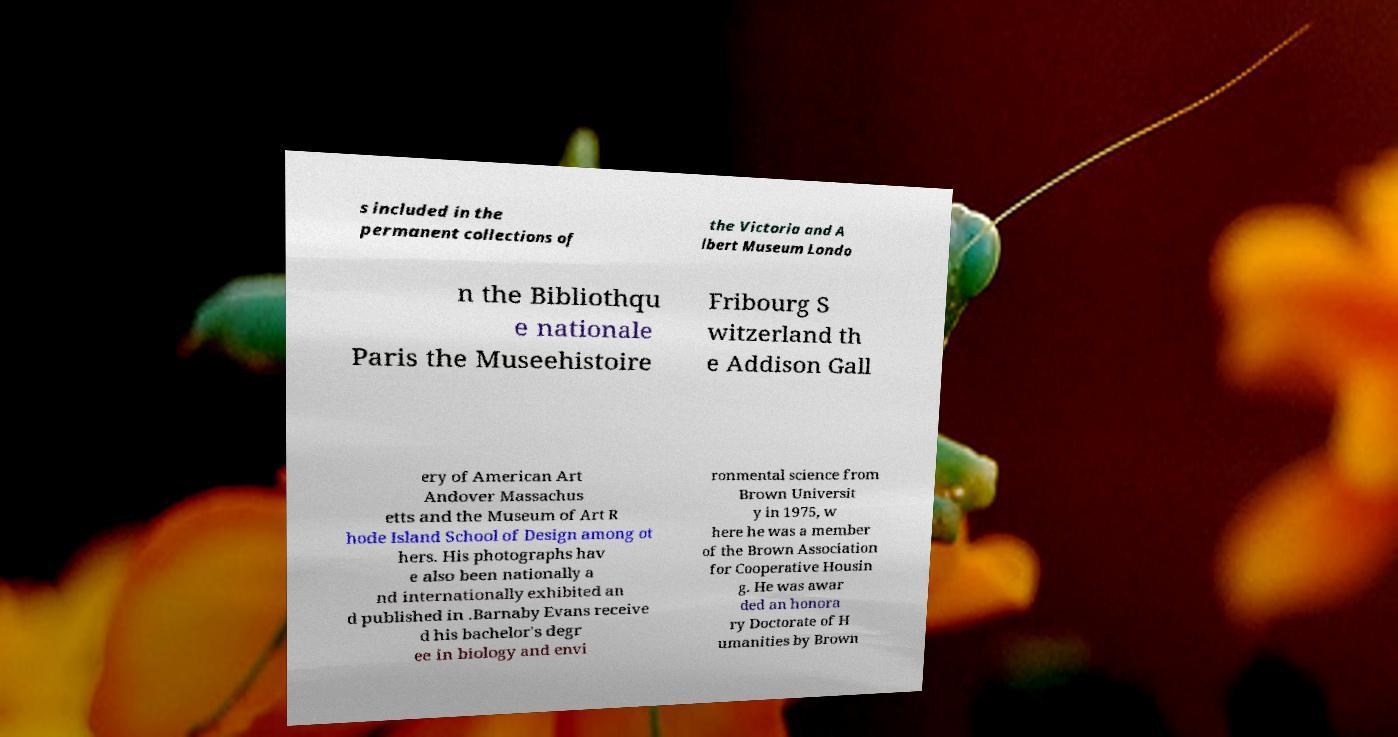What messages or text are displayed in this image? I need them in a readable, typed format. s included in the permanent collections of the Victoria and A lbert Museum Londo n the Bibliothqu e nationale Paris the Museehistoire Fribourg S witzerland th e Addison Gall ery of American Art Andover Massachus etts and the Museum of Art R hode Island School of Design among ot hers. His photographs hav e also been nationally a nd internationally exhibited an d published in .Barnaby Evans receive d his bachelor's degr ee in biology and envi ronmental science from Brown Universit y in 1975, w here he was a member of the Brown Association for Cooperative Housin g. He was awar ded an honora ry Doctorate of H umanities by Brown 